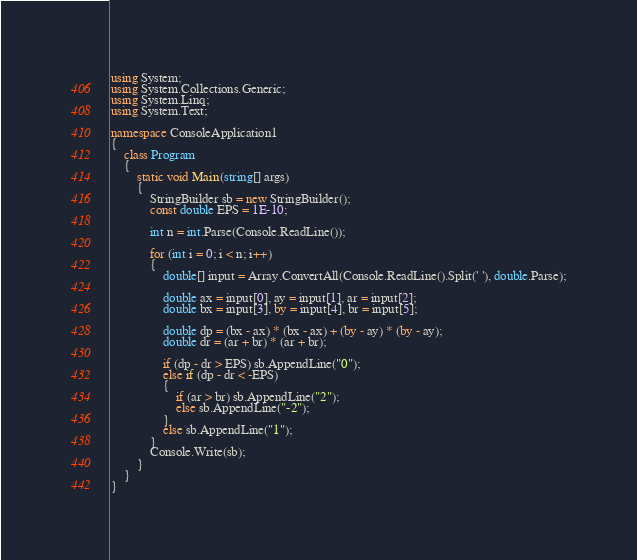<code> <loc_0><loc_0><loc_500><loc_500><_C#_>using System;
using System.Collections.Generic;
using System.Linq;
using System.Text;

namespace ConsoleApplication1
{
    class Program
    {
        static void Main(string[] args)
        {
            StringBuilder sb = new StringBuilder();
            const double EPS = 1E-10;

            int n = int.Parse(Console.ReadLine());

            for (int i = 0; i < n; i++)
            {
                double[] input = Array.ConvertAll(Console.ReadLine().Split(' '), double.Parse);

                double ax = input[0], ay = input[1], ar = input[2];
                double bx = input[3], by = input[4], br = input[5];

                double dp = (bx - ax) * (bx - ax) + (by - ay) * (by - ay);
                double dr = (ar + br) * (ar + br);

                if (dp - dr > EPS) sb.AppendLine("0");
                else if (dp - dr < -EPS)
                {
                    if (ar > br) sb.AppendLine("2");
                    else sb.AppendLine("-2");
                }
                else sb.AppendLine("1");
            }
            Console.Write(sb);
        }
    }
}</code> 